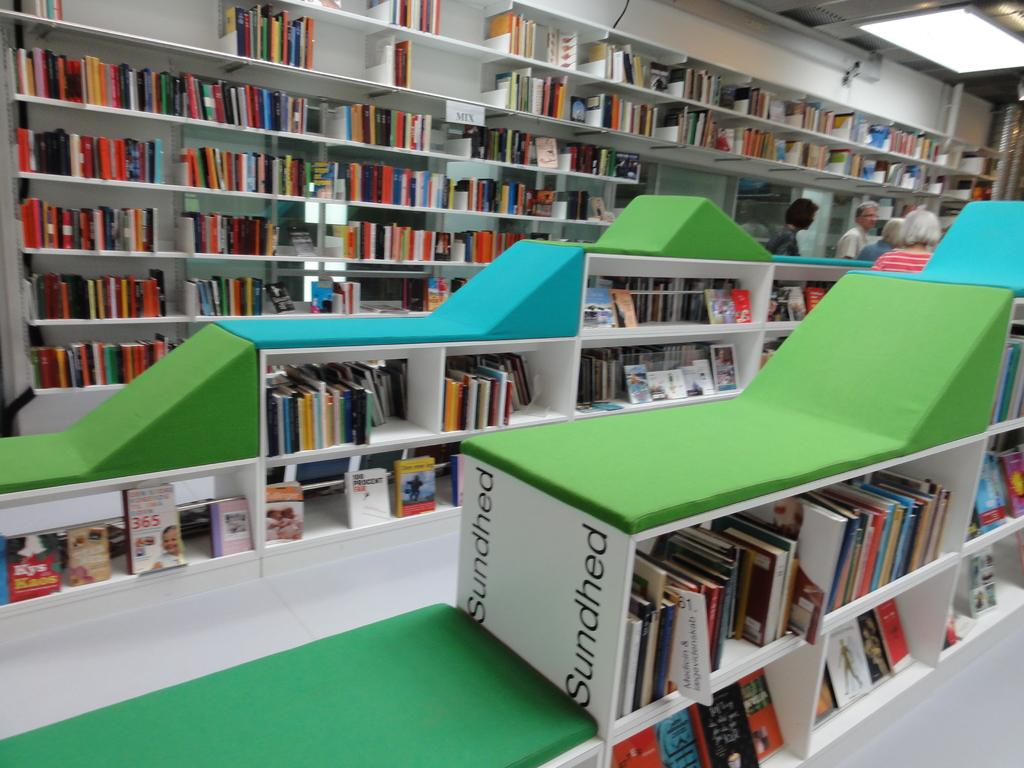<image>
Give a short and clear explanation of the subsequent image. A desk in green with the word Sundhed visible. 